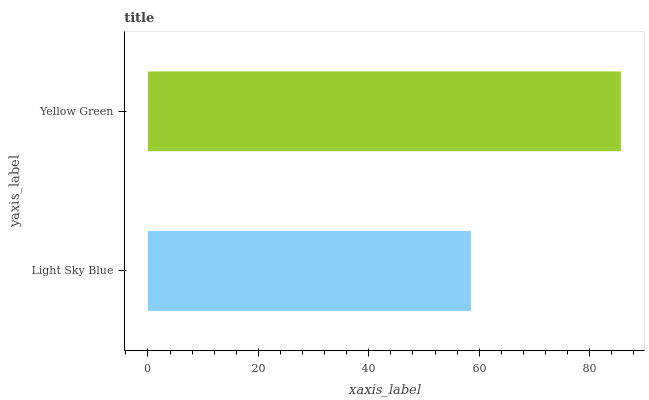Is Light Sky Blue the minimum?
Answer yes or no. Yes. Is Yellow Green the maximum?
Answer yes or no. Yes. Is Yellow Green the minimum?
Answer yes or no. No. Is Yellow Green greater than Light Sky Blue?
Answer yes or no. Yes. Is Light Sky Blue less than Yellow Green?
Answer yes or no. Yes. Is Light Sky Blue greater than Yellow Green?
Answer yes or no. No. Is Yellow Green less than Light Sky Blue?
Answer yes or no. No. Is Yellow Green the high median?
Answer yes or no. Yes. Is Light Sky Blue the low median?
Answer yes or no. Yes. Is Light Sky Blue the high median?
Answer yes or no. No. Is Yellow Green the low median?
Answer yes or no. No. 